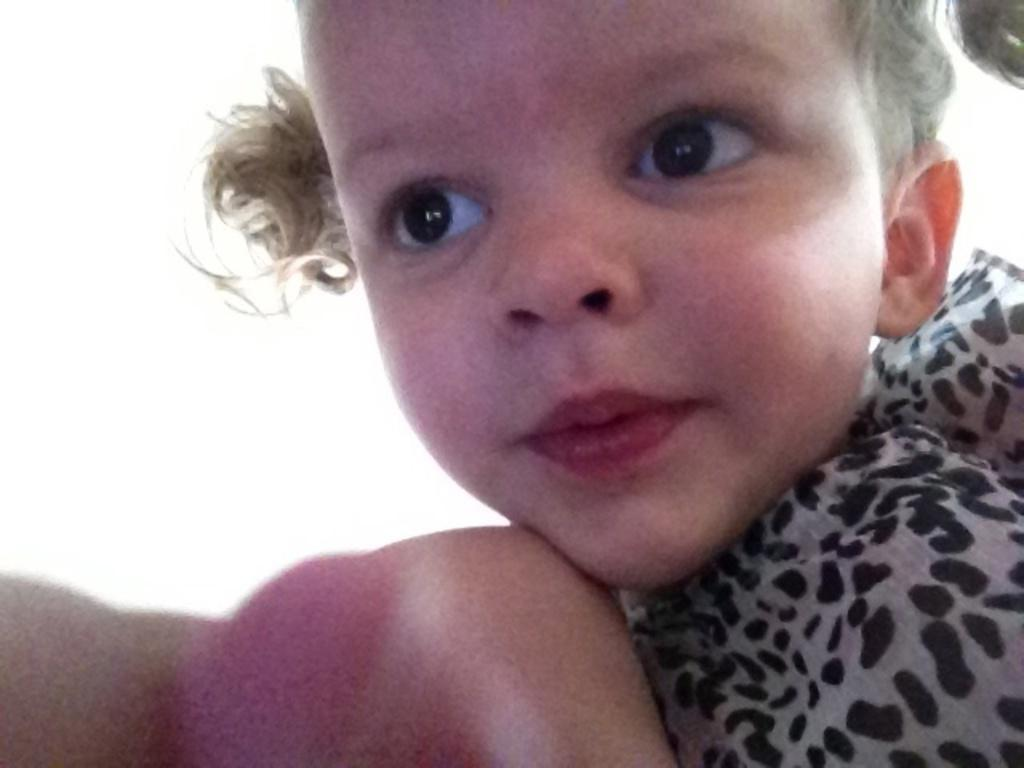What is the main subject of the image? There is a person in the image. Can you describe the person's attire? The person is wearing a black and ash color dress. What is the color of the background in the image? The background of the image is white. Is the person in the image being held in a jail cell? There is no indication of a jail or jail cell in the image. Can you see a carriage in the background of the image? There is no carriage present in the image; the background is white. 